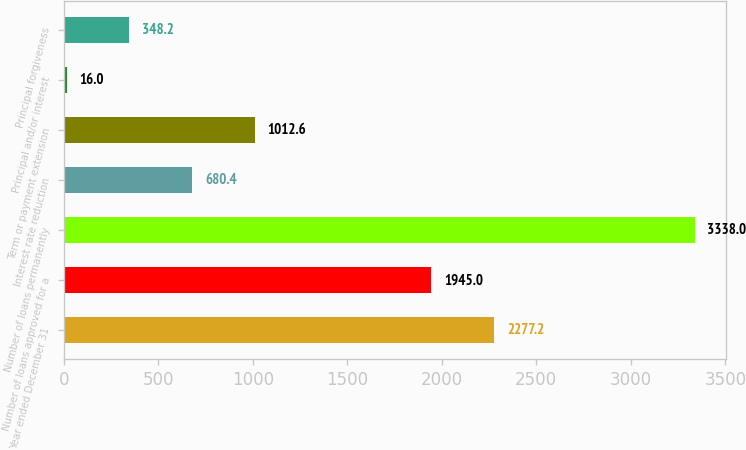Convert chart. <chart><loc_0><loc_0><loc_500><loc_500><bar_chart><fcel>Year ended December 31<fcel>Number of loans approved for a<fcel>Number of loans permanently<fcel>Interest rate reduction<fcel>Term or payment extension<fcel>Principal and/or interest<fcel>Principal forgiveness<nl><fcel>2277.2<fcel>1945<fcel>3338<fcel>680.4<fcel>1012.6<fcel>16<fcel>348.2<nl></chart> 